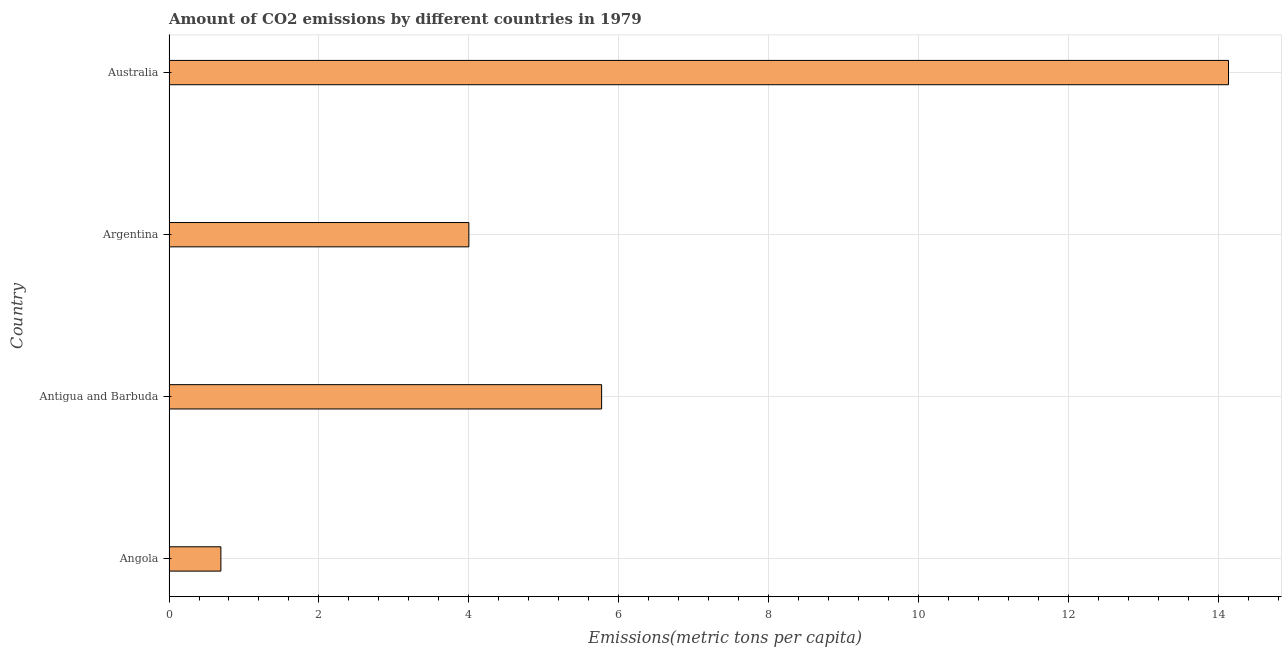Does the graph contain any zero values?
Make the answer very short. No. What is the title of the graph?
Your response must be concise. Amount of CO2 emissions by different countries in 1979. What is the label or title of the X-axis?
Your response must be concise. Emissions(metric tons per capita). What is the label or title of the Y-axis?
Provide a succinct answer. Country. What is the amount of co2 emissions in Argentina?
Give a very brief answer. 4. Across all countries, what is the maximum amount of co2 emissions?
Offer a very short reply. 14.13. Across all countries, what is the minimum amount of co2 emissions?
Offer a very short reply. 0.69. In which country was the amount of co2 emissions maximum?
Give a very brief answer. Australia. In which country was the amount of co2 emissions minimum?
Your answer should be very brief. Angola. What is the sum of the amount of co2 emissions?
Offer a terse response. 24.59. What is the difference between the amount of co2 emissions in Angola and Australia?
Your answer should be very brief. -13.44. What is the average amount of co2 emissions per country?
Provide a short and direct response. 6.15. What is the median amount of co2 emissions?
Give a very brief answer. 4.88. In how many countries, is the amount of co2 emissions greater than 5.2 metric tons per capita?
Ensure brevity in your answer.  2. What is the ratio of the amount of co2 emissions in Antigua and Barbuda to that in Australia?
Your response must be concise. 0.41. Is the amount of co2 emissions in Angola less than that in Australia?
Make the answer very short. Yes. What is the difference between the highest and the second highest amount of co2 emissions?
Keep it short and to the point. 8.36. Is the sum of the amount of co2 emissions in Angola and Australia greater than the maximum amount of co2 emissions across all countries?
Your response must be concise. Yes. What is the difference between the highest and the lowest amount of co2 emissions?
Your answer should be very brief. 13.44. How many bars are there?
Offer a terse response. 4. Are all the bars in the graph horizontal?
Your response must be concise. Yes. How many countries are there in the graph?
Ensure brevity in your answer.  4. Are the values on the major ticks of X-axis written in scientific E-notation?
Give a very brief answer. No. What is the Emissions(metric tons per capita) of Angola?
Give a very brief answer. 0.69. What is the Emissions(metric tons per capita) in Antigua and Barbuda?
Ensure brevity in your answer.  5.77. What is the Emissions(metric tons per capita) in Argentina?
Your answer should be compact. 4. What is the Emissions(metric tons per capita) of Australia?
Your response must be concise. 14.13. What is the difference between the Emissions(metric tons per capita) in Angola and Antigua and Barbuda?
Provide a short and direct response. -5.08. What is the difference between the Emissions(metric tons per capita) in Angola and Argentina?
Provide a succinct answer. -3.31. What is the difference between the Emissions(metric tons per capita) in Angola and Australia?
Provide a succinct answer. -13.44. What is the difference between the Emissions(metric tons per capita) in Antigua and Barbuda and Argentina?
Offer a very short reply. 1.77. What is the difference between the Emissions(metric tons per capita) in Antigua and Barbuda and Australia?
Make the answer very short. -8.36. What is the difference between the Emissions(metric tons per capita) in Argentina and Australia?
Offer a terse response. -10.13. What is the ratio of the Emissions(metric tons per capita) in Angola to that in Antigua and Barbuda?
Give a very brief answer. 0.12. What is the ratio of the Emissions(metric tons per capita) in Angola to that in Argentina?
Give a very brief answer. 0.17. What is the ratio of the Emissions(metric tons per capita) in Angola to that in Australia?
Provide a succinct answer. 0.05. What is the ratio of the Emissions(metric tons per capita) in Antigua and Barbuda to that in Argentina?
Your response must be concise. 1.44. What is the ratio of the Emissions(metric tons per capita) in Antigua and Barbuda to that in Australia?
Make the answer very short. 0.41. What is the ratio of the Emissions(metric tons per capita) in Argentina to that in Australia?
Your response must be concise. 0.28. 